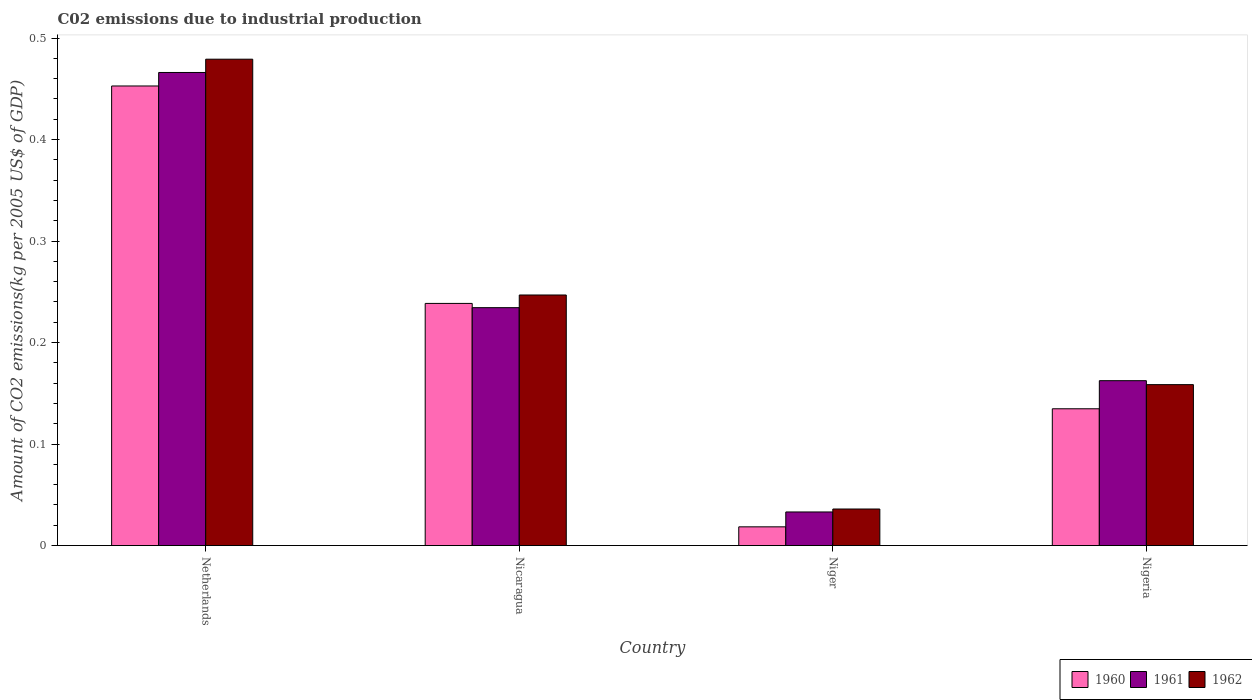How many groups of bars are there?
Your response must be concise. 4. Are the number of bars per tick equal to the number of legend labels?
Your response must be concise. Yes. Are the number of bars on each tick of the X-axis equal?
Provide a succinct answer. Yes. How many bars are there on the 2nd tick from the right?
Offer a terse response. 3. What is the label of the 4th group of bars from the left?
Your response must be concise. Nigeria. In how many cases, is the number of bars for a given country not equal to the number of legend labels?
Your response must be concise. 0. What is the amount of CO2 emitted due to industrial production in 1961 in Netherlands?
Provide a succinct answer. 0.47. Across all countries, what is the maximum amount of CO2 emitted due to industrial production in 1960?
Your response must be concise. 0.45. Across all countries, what is the minimum amount of CO2 emitted due to industrial production in 1961?
Keep it short and to the point. 0.03. In which country was the amount of CO2 emitted due to industrial production in 1960 maximum?
Your answer should be compact. Netherlands. In which country was the amount of CO2 emitted due to industrial production in 1960 minimum?
Provide a short and direct response. Niger. What is the total amount of CO2 emitted due to industrial production in 1961 in the graph?
Ensure brevity in your answer.  0.9. What is the difference between the amount of CO2 emitted due to industrial production in 1962 in Niger and that in Nigeria?
Offer a terse response. -0.12. What is the difference between the amount of CO2 emitted due to industrial production in 1960 in Niger and the amount of CO2 emitted due to industrial production in 1962 in Netherlands?
Offer a very short reply. -0.46. What is the average amount of CO2 emitted due to industrial production in 1962 per country?
Provide a short and direct response. 0.23. What is the difference between the amount of CO2 emitted due to industrial production of/in 1960 and amount of CO2 emitted due to industrial production of/in 1962 in Niger?
Make the answer very short. -0.02. What is the ratio of the amount of CO2 emitted due to industrial production in 1961 in Nicaragua to that in Nigeria?
Give a very brief answer. 1.44. Is the amount of CO2 emitted due to industrial production in 1961 in Netherlands less than that in Nicaragua?
Provide a short and direct response. No. Is the difference between the amount of CO2 emitted due to industrial production in 1960 in Netherlands and Nigeria greater than the difference between the amount of CO2 emitted due to industrial production in 1962 in Netherlands and Nigeria?
Your answer should be compact. No. What is the difference between the highest and the second highest amount of CO2 emitted due to industrial production in 1961?
Ensure brevity in your answer.  0.3. What is the difference between the highest and the lowest amount of CO2 emitted due to industrial production in 1962?
Keep it short and to the point. 0.44. Is the sum of the amount of CO2 emitted due to industrial production in 1962 in Netherlands and Nigeria greater than the maximum amount of CO2 emitted due to industrial production in 1961 across all countries?
Give a very brief answer. Yes. What does the 1st bar from the right in Nigeria represents?
Ensure brevity in your answer.  1962. How many bars are there?
Your response must be concise. 12. Are all the bars in the graph horizontal?
Give a very brief answer. No. Are the values on the major ticks of Y-axis written in scientific E-notation?
Make the answer very short. No. Does the graph contain any zero values?
Your answer should be compact. No. Does the graph contain grids?
Give a very brief answer. No. What is the title of the graph?
Your answer should be very brief. C02 emissions due to industrial production. Does "1972" appear as one of the legend labels in the graph?
Offer a terse response. No. What is the label or title of the X-axis?
Give a very brief answer. Country. What is the label or title of the Y-axis?
Make the answer very short. Amount of CO2 emissions(kg per 2005 US$ of GDP). What is the Amount of CO2 emissions(kg per 2005 US$ of GDP) of 1960 in Netherlands?
Make the answer very short. 0.45. What is the Amount of CO2 emissions(kg per 2005 US$ of GDP) in 1961 in Netherlands?
Make the answer very short. 0.47. What is the Amount of CO2 emissions(kg per 2005 US$ of GDP) of 1962 in Netherlands?
Offer a very short reply. 0.48. What is the Amount of CO2 emissions(kg per 2005 US$ of GDP) of 1960 in Nicaragua?
Provide a short and direct response. 0.24. What is the Amount of CO2 emissions(kg per 2005 US$ of GDP) in 1961 in Nicaragua?
Ensure brevity in your answer.  0.23. What is the Amount of CO2 emissions(kg per 2005 US$ of GDP) in 1962 in Nicaragua?
Keep it short and to the point. 0.25. What is the Amount of CO2 emissions(kg per 2005 US$ of GDP) of 1960 in Niger?
Provide a short and direct response. 0.02. What is the Amount of CO2 emissions(kg per 2005 US$ of GDP) of 1961 in Niger?
Ensure brevity in your answer.  0.03. What is the Amount of CO2 emissions(kg per 2005 US$ of GDP) of 1962 in Niger?
Give a very brief answer. 0.04. What is the Amount of CO2 emissions(kg per 2005 US$ of GDP) of 1960 in Nigeria?
Offer a terse response. 0.13. What is the Amount of CO2 emissions(kg per 2005 US$ of GDP) of 1961 in Nigeria?
Provide a succinct answer. 0.16. What is the Amount of CO2 emissions(kg per 2005 US$ of GDP) in 1962 in Nigeria?
Provide a short and direct response. 0.16. Across all countries, what is the maximum Amount of CO2 emissions(kg per 2005 US$ of GDP) of 1960?
Make the answer very short. 0.45. Across all countries, what is the maximum Amount of CO2 emissions(kg per 2005 US$ of GDP) in 1961?
Your response must be concise. 0.47. Across all countries, what is the maximum Amount of CO2 emissions(kg per 2005 US$ of GDP) of 1962?
Offer a very short reply. 0.48. Across all countries, what is the minimum Amount of CO2 emissions(kg per 2005 US$ of GDP) of 1960?
Provide a short and direct response. 0.02. Across all countries, what is the minimum Amount of CO2 emissions(kg per 2005 US$ of GDP) in 1961?
Give a very brief answer. 0.03. Across all countries, what is the minimum Amount of CO2 emissions(kg per 2005 US$ of GDP) in 1962?
Your response must be concise. 0.04. What is the total Amount of CO2 emissions(kg per 2005 US$ of GDP) of 1960 in the graph?
Give a very brief answer. 0.84. What is the total Amount of CO2 emissions(kg per 2005 US$ of GDP) in 1961 in the graph?
Provide a short and direct response. 0.9. What is the total Amount of CO2 emissions(kg per 2005 US$ of GDP) of 1962 in the graph?
Make the answer very short. 0.92. What is the difference between the Amount of CO2 emissions(kg per 2005 US$ of GDP) in 1960 in Netherlands and that in Nicaragua?
Give a very brief answer. 0.21. What is the difference between the Amount of CO2 emissions(kg per 2005 US$ of GDP) of 1961 in Netherlands and that in Nicaragua?
Provide a succinct answer. 0.23. What is the difference between the Amount of CO2 emissions(kg per 2005 US$ of GDP) of 1962 in Netherlands and that in Nicaragua?
Your response must be concise. 0.23. What is the difference between the Amount of CO2 emissions(kg per 2005 US$ of GDP) of 1960 in Netherlands and that in Niger?
Your answer should be very brief. 0.43. What is the difference between the Amount of CO2 emissions(kg per 2005 US$ of GDP) in 1961 in Netherlands and that in Niger?
Offer a terse response. 0.43. What is the difference between the Amount of CO2 emissions(kg per 2005 US$ of GDP) of 1962 in Netherlands and that in Niger?
Your response must be concise. 0.44. What is the difference between the Amount of CO2 emissions(kg per 2005 US$ of GDP) of 1960 in Netherlands and that in Nigeria?
Ensure brevity in your answer.  0.32. What is the difference between the Amount of CO2 emissions(kg per 2005 US$ of GDP) in 1961 in Netherlands and that in Nigeria?
Offer a terse response. 0.3. What is the difference between the Amount of CO2 emissions(kg per 2005 US$ of GDP) of 1962 in Netherlands and that in Nigeria?
Provide a succinct answer. 0.32. What is the difference between the Amount of CO2 emissions(kg per 2005 US$ of GDP) of 1960 in Nicaragua and that in Niger?
Your answer should be compact. 0.22. What is the difference between the Amount of CO2 emissions(kg per 2005 US$ of GDP) in 1961 in Nicaragua and that in Niger?
Your response must be concise. 0.2. What is the difference between the Amount of CO2 emissions(kg per 2005 US$ of GDP) in 1962 in Nicaragua and that in Niger?
Ensure brevity in your answer.  0.21. What is the difference between the Amount of CO2 emissions(kg per 2005 US$ of GDP) of 1960 in Nicaragua and that in Nigeria?
Your answer should be very brief. 0.1. What is the difference between the Amount of CO2 emissions(kg per 2005 US$ of GDP) in 1961 in Nicaragua and that in Nigeria?
Provide a short and direct response. 0.07. What is the difference between the Amount of CO2 emissions(kg per 2005 US$ of GDP) of 1962 in Nicaragua and that in Nigeria?
Give a very brief answer. 0.09. What is the difference between the Amount of CO2 emissions(kg per 2005 US$ of GDP) of 1960 in Niger and that in Nigeria?
Your answer should be very brief. -0.12. What is the difference between the Amount of CO2 emissions(kg per 2005 US$ of GDP) of 1961 in Niger and that in Nigeria?
Offer a very short reply. -0.13. What is the difference between the Amount of CO2 emissions(kg per 2005 US$ of GDP) in 1962 in Niger and that in Nigeria?
Give a very brief answer. -0.12. What is the difference between the Amount of CO2 emissions(kg per 2005 US$ of GDP) in 1960 in Netherlands and the Amount of CO2 emissions(kg per 2005 US$ of GDP) in 1961 in Nicaragua?
Your answer should be compact. 0.22. What is the difference between the Amount of CO2 emissions(kg per 2005 US$ of GDP) in 1960 in Netherlands and the Amount of CO2 emissions(kg per 2005 US$ of GDP) in 1962 in Nicaragua?
Provide a short and direct response. 0.21. What is the difference between the Amount of CO2 emissions(kg per 2005 US$ of GDP) in 1961 in Netherlands and the Amount of CO2 emissions(kg per 2005 US$ of GDP) in 1962 in Nicaragua?
Your answer should be very brief. 0.22. What is the difference between the Amount of CO2 emissions(kg per 2005 US$ of GDP) of 1960 in Netherlands and the Amount of CO2 emissions(kg per 2005 US$ of GDP) of 1961 in Niger?
Offer a terse response. 0.42. What is the difference between the Amount of CO2 emissions(kg per 2005 US$ of GDP) in 1960 in Netherlands and the Amount of CO2 emissions(kg per 2005 US$ of GDP) in 1962 in Niger?
Provide a succinct answer. 0.42. What is the difference between the Amount of CO2 emissions(kg per 2005 US$ of GDP) of 1961 in Netherlands and the Amount of CO2 emissions(kg per 2005 US$ of GDP) of 1962 in Niger?
Give a very brief answer. 0.43. What is the difference between the Amount of CO2 emissions(kg per 2005 US$ of GDP) of 1960 in Netherlands and the Amount of CO2 emissions(kg per 2005 US$ of GDP) of 1961 in Nigeria?
Your answer should be compact. 0.29. What is the difference between the Amount of CO2 emissions(kg per 2005 US$ of GDP) of 1960 in Netherlands and the Amount of CO2 emissions(kg per 2005 US$ of GDP) of 1962 in Nigeria?
Offer a terse response. 0.29. What is the difference between the Amount of CO2 emissions(kg per 2005 US$ of GDP) in 1961 in Netherlands and the Amount of CO2 emissions(kg per 2005 US$ of GDP) in 1962 in Nigeria?
Provide a short and direct response. 0.31. What is the difference between the Amount of CO2 emissions(kg per 2005 US$ of GDP) in 1960 in Nicaragua and the Amount of CO2 emissions(kg per 2005 US$ of GDP) in 1961 in Niger?
Your answer should be compact. 0.21. What is the difference between the Amount of CO2 emissions(kg per 2005 US$ of GDP) in 1960 in Nicaragua and the Amount of CO2 emissions(kg per 2005 US$ of GDP) in 1962 in Niger?
Your answer should be very brief. 0.2. What is the difference between the Amount of CO2 emissions(kg per 2005 US$ of GDP) of 1961 in Nicaragua and the Amount of CO2 emissions(kg per 2005 US$ of GDP) of 1962 in Niger?
Keep it short and to the point. 0.2. What is the difference between the Amount of CO2 emissions(kg per 2005 US$ of GDP) in 1960 in Nicaragua and the Amount of CO2 emissions(kg per 2005 US$ of GDP) in 1961 in Nigeria?
Give a very brief answer. 0.08. What is the difference between the Amount of CO2 emissions(kg per 2005 US$ of GDP) of 1960 in Nicaragua and the Amount of CO2 emissions(kg per 2005 US$ of GDP) of 1962 in Nigeria?
Offer a terse response. 0.08. What is the difference between the Amount of CO2 emissions(kg per 2005 US$ of GDP) of 1961 in Nicaragua and the Amount of CO2 emissions(kg per 2005 US$ of GDP) of 1962 in Nigeria?
Your response must be concise. 0.08. What is the difference between the Amount of CO2 emissions(kg per 2005 US$ of GDP) of 1960 in Niger and the Amount of CO2 emissions(kg per 2005 US$ of GDP) of 1961 in Nigeria?
Provide a short and direct response. -0.14. What is the difference between the Amount of CO2 emissions(kg per 2005 US$ of GDP) of 1960 in Niger and the Amount of CO2 emissions(kg per 2005 US$ of GDP) of 1962 in Nigeria?
Offer a very short reply. -0.14. What is the difference between the Amount of CO2 emissions(kg per 2005 US$ of GDP) in 1961 in Niger and the Amount of CO2 emissions(kg per 2005 US$ of GDP) in 1962 in Nigeria?
Your response must be concise. -0.13. What is the average Amount of CO2 emissions(kg per 2005 US$ of GDP) in 1960 per country?
Give a very brief answer. 0.21. What is the average Amount of CO2 emissions(kg per 2005 US$ of GDP) in 1961 per country?
Your answer should be very brief. 0.22. What is the average Amount of CO2 emissions(kg per 2005 US$ of GDP) of 1962 per country?
Make the answer very short. 0.23. What is the difference between the Amount of CO2 emissions(kg per 2005 US$ of GDP) in 1960 and Amount of CO2 emissions(kg per 2005 US$ of GDP) in 1961 in Netherlands?
Offer a very short reply. -0.01. What is the difference between the Amount of CO2 emissions(kg per 2005 US$ of GDP) of 1960 and Amount of CO2 emissions(kg per 2005 US$ of GDP) of 1962 in Netherlands?
Ensure brevity in your answer.  -0.03. What is the difference between the Amount of CO2 emissions(kg per 2005 US$ of GDP) in 1961 and Amount of CO2 emissions(kg per 2005 US$ of GDP) in 1962 in Netherlands?
Your answer should be compact. -0.01. What is the difference between the Amount of CO2 emissions(kg per 2005 US$ of GDP) of 1960 and Amount of CO2 emissions(kg per 2005 US$ of GDP) of 1961 in Nicaragua?
Provide a succinct answer. 0. What is the difference between the Amount of CO2 emissions(kg per 2005 US$ of GDP) in 1960 and Amount of CO2 emissions(kg per 2005 US$ of GDP) in 1962 in Nicaragua?
Your response must be concise. -0.01. What is the difference between the Amount of CO2 emissions(kg per 2005 US$ of GDP) of 1961 and Amount of CO2 emissions(kg per 2005 US$ of GDP) of 1962 in Nicaragua?
Your answer should be very brief. -0.01. What is the difference between the Amount of CO2 emissions(kg per 2005 US$ of GDP) of 1960 and Amount of CO2 emissions(kg per 2005 US$ of GDP) of 1961 in Niger?
Provide a succinct answer. -0.01. What is the difference between the Amount of CO2 emissions(kg per 2005 US$ of GDP) of 1960 and Amount of CO2 emissions(kg per 2005 US$ of GDP) of 1962 in Niger?
Provide a short and direct response. -0.02. What is the difference between the Amount of CO2 emissions(kg per 2005 US$ of GDP) in 1961 and Amount of CO2 emissions(kg per 2005 US$ of GDP) in 1962 in Niger?
Your answer should be very brief. -0. What is the difference between the Amount of CO2 emissions(kg per 2005 US$ of GDP) of 1960 and Amount of CO2 emissions(kg per 2005 US$ of GDP) of 1961 in Nigeria?
Your answer should be very brief. -0.03. What is the difference between the Amount of CO2 emissions(kg per 2005 US$ of GDP) of 1960 and Amount of CO2 emissions(kg per 2005 US$ of GDP) of 1962 in Nigeria?
Ensure brevity in your answer.  -0.02. What is the difference between the Amount of CO2 emissions(kg per 2005 US$ of GDP) of 1961 and Amount of CO2 emissions(kg per 2005 US$ of GDP) of 1962 in Nigeria?
Your answer should be compact. 0. What is the ratio of the Amount of CO2 emissions(kg per 2005 US$ of GDP) of 1960 in Netherlands to that in Nicaragua?
Offer a very short reply. 1.9. What is the ratio of the Amount of CO2 emissions(kg per 2005 US$ of GDP) of 1961 in Netherlands to that in Nicaragua?
Your answer should be compact. 1.99. What is the ratio of the Amount of CO2 emissions(kg per 2005 US$ of GDP) of 1962 in Netherlands to that in Nicaragua?
Offer a very short reply. 1.94. What is the ratio of the Amount of CO2 emissions(kg per 2005 US$ of GDP) in 1960 in Netherlands to that in Niger?
Offer a terse response. 24.53. What is the ratio of the Amount of CO2 emissions(kg per 2005 US$ of GDP) in 1961 in Netherlands to that in Niger?
Your answer should be compact. 14.08. What is the ratio of the Amount of CO2 emissions(kg per 2005 US$ of GDP) of 1962 in Netherlands to that in Niger?
Give a very brief answer. 13.3. What is the ratio of the Amount of CO2 emissions(kg per 2005 US$ of GDP) in 1960 in Netherlands to that in Nigeria?
Ensure brevity in your answer.  3.36. What is the ratio of the Amount of CO2 emissions(kg per 2005 US$ of GDP) of 1961 in Netherlands to that in Nigeria?
Give a very brief answer. 2.87. What is the ratio of the Amount of CO2 emissions(kg per 2005 US$ of GDP) of 1962 in Netherlands to that in Nigeria?
Offer a very short reply. 3.02. What is the ratio of the Amount of CO2 emissions(kg per 2005 US$ of GDP) in 1960 in Nicaragua to that in Niger?
Your response must be concise. 12.93. What is the ratio of the Amount of CO2 emissions(kg per 2005 US$ of GDP) of 1961 in Nicaragua to that in Niger?
Your response must be concise. 7.08. What is the ratio of the Amount of CO2 emissions(kg per 2005 US$ of GDP) of 1962 in Nicaragua to that in Niger?
Ensure brevity in your answer.  6.85. What is the ratio of the Amount of CO2 emissions(kg per 2005 US$ of GDP) in 1960 in Nicaragua to that in Nigeria?
Keep it short and to the point. 1.77. What is the ratio of the Amount of CO2 emissions(kg per 2005 US$ of GDP) in 1961 in Nicaragua to that in Nigeria?
Give a very brief answer. 1.44. What is the ratio of the Amount of CO2 emissions(kg per 2005 US$ of GDP) in 1962 in Nicaragua to that in Nigeria?
Offer a terse response. 1.56. What is the ratio of the Amount of CO2 emissions(kg per 2005 US$ of GDP) of 1960 in Niger to that in Nigeria?
Give a very brief answer. 0.14. What is the ratio of the Amount of CO2 emissions(kg per 2005 US$ of GDP) in 1961 in Niger to that in Nigeria?
Offer a very short reply. 0.2. What is the ratio of the Amount of CO2 emissions(kg per 2005 US$ of GDP) of 1962 in Niger to that in Nigeria?
Give a very brief answer. 0.23. What is the difference between the highest and the second highest Amount of CO2 emissions(kg per 2005 US$ of GDP) in 1960?
Offer a very short reply. 0.21. What is the difference between the highest and the second highest Amount of CO2 emissions(kg per 2005 US$ of GDP) of 1961?
Ensure brevity in your answer.  0.23. What is the difference between the highest and the second highest Amount of CO2 emissions(kg per 2005 US$ of GDP) of 1962?
Make the answer very short. 0.23. What is the difference between the highest and the lowest Amount of CO2 emissions(kg per 2005 US$ of GDP) in 1960?
Your answer should be very brief. 0.43. What is the difference between the highest and the lowest Amount of CO2 emissions(kg per 2005 US$ of GDP) in 1961?
Ensure brevity in your answer.  0.43. What is the difference between the highest and the lowest Amount of CO2 emissions(kg per 2005 US$ of GDP) of 1962?
Ensure brevity in your answer.  0.44. 